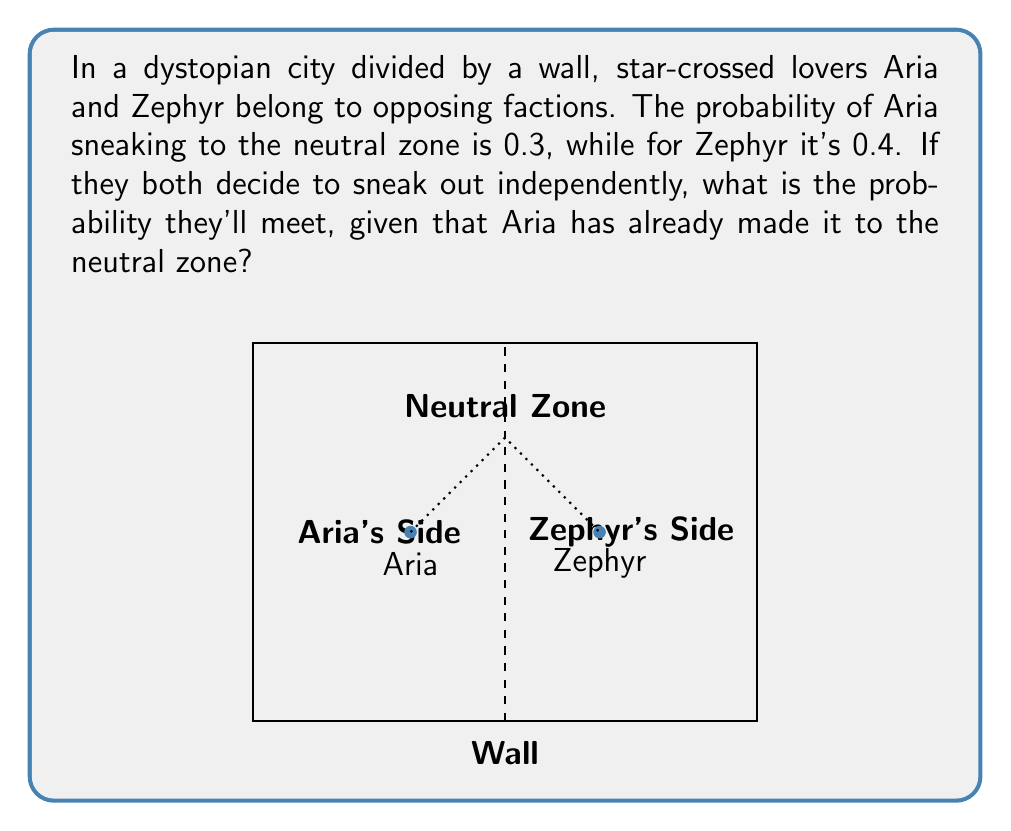Help me with this question. Let's approach this step-by-step using conditional probability:

1) Define events:
   A: Aria sneaks to the neutral zone
   Z: Zephyr sneaks to the neutral zone

2) Given probabilities:
   P(A) = 0.3
   P(Z) = 0.4

3) We need to find P(Z|A), the probability that Zephyr sneaks out given that Aria has already done so.

4) In this case, the events are independent, so:
   P(Z|A) = P(Z)

5) Therefore:
   P(Z|A) = 0.4

The conditional probability formula is:

$$ P(Z|A) = \frac{P(Z \cap A)}{P(A)} $$

But since the events are independent:

$$ P(Z|A) = P(Z) = 0.4 $$

This means that the probability of Zephyr sneaking out remains 0.4, regardless of whether Aria has already made it to the neutral zone or not.
Answer: 0.4 